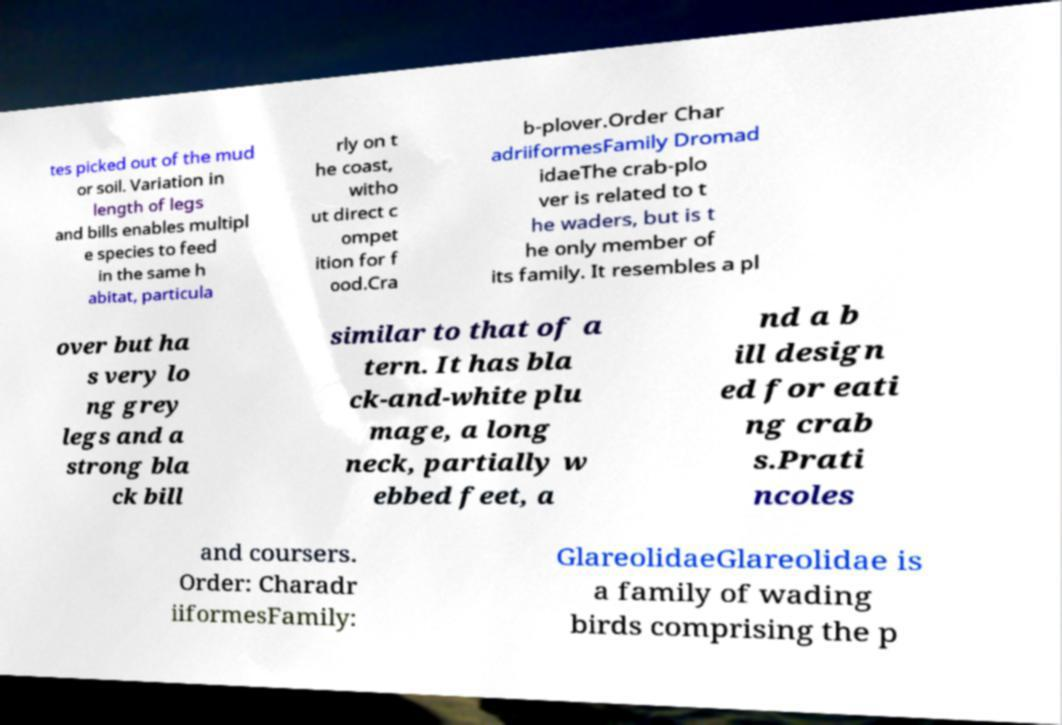Could you assist in decoding the text presented in this image and type it out clearly? tes picked out of the mud or soil. Variation in length of legs and bills enables multipl e species to feed in the same h abitat, particula rly on t he coast, witho ut direct c ompet ition for f ood.Cra b-plover.Order Char adriiformesFamily Dromad idaeThe crab-plo ver is related to t he waders, but is t he only member of its family. It resembles a pl over but ha s very lo ng grey legs and a strong bla ck bill similar to that of a tern. It has bla ck-and-white plu mage, a long neck, partially w ebbed feet, a nd a b ill design ed for eati ng crab s.Prati ncoles and coursers. Order: Charadr iiformesFamily: GlareolidaeGlareolidae is a family of wading birds comprising the p 